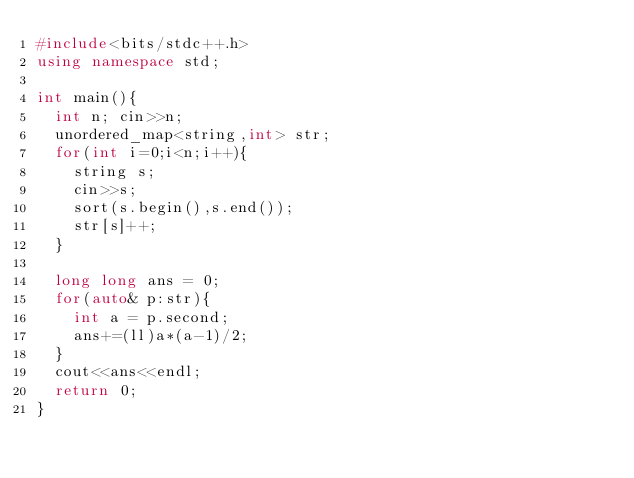<code> <loc_0><loc_0><loc_500><loc_500><_C++_>#include<bits/stdc++.h>
using namespace std;

int main(){
  int n; cin>>n;
  unordered_map<string,int> str;
  for(int i=0;i<n;i++){
    string s;
    cin>>s;
    sort(s.begin(),s.end());
    str[s]++;
  }
  
  long long ans = 0;
  for(auto& p:str){
    int a = p.second;
    ans+=(ll)a*(a-1)/2;
  }
  cout<<ans<<endl;
  return 0;
}</code> 